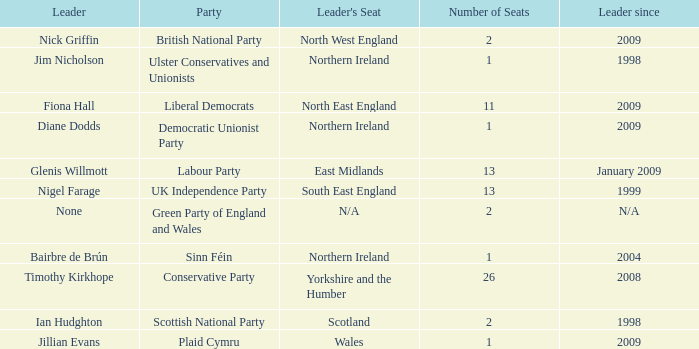Which party does Timothy Kirkhope lead? Conservative Party. 